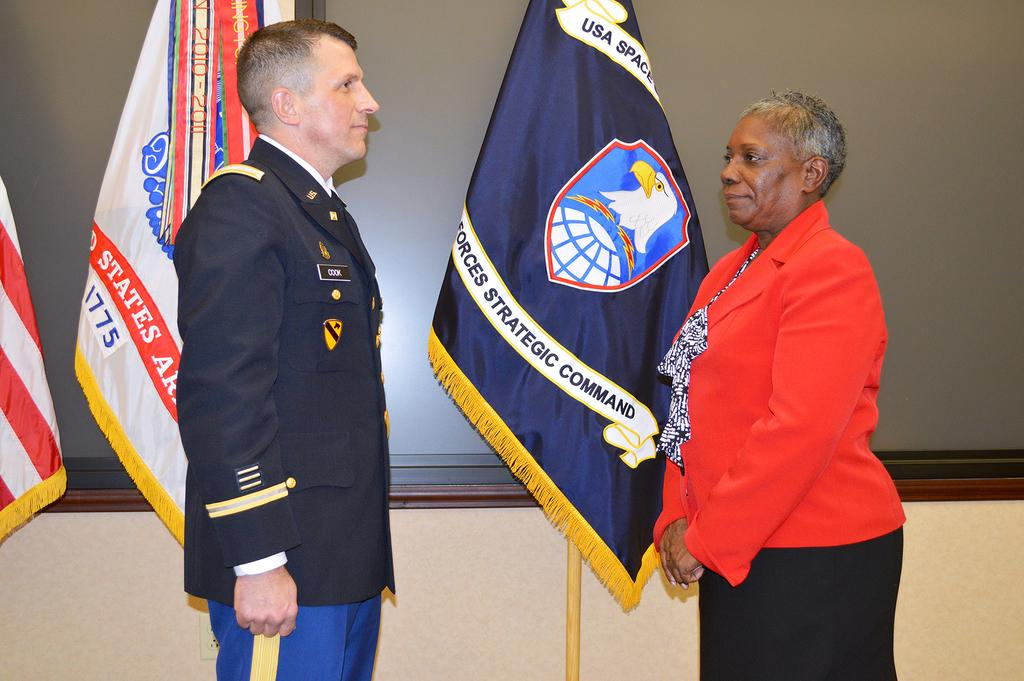<image>
Give a short and clear explanation of the subsequent image. a man in uniform with the name Cook standing in front of flags and woman in red 